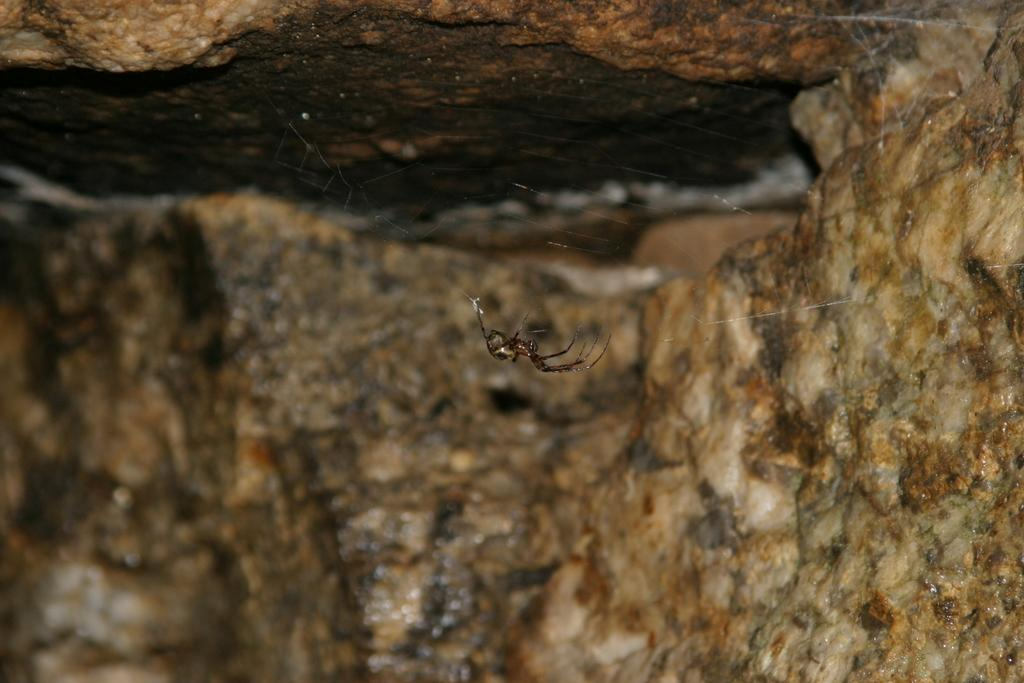What is the main subject of the image? There is a spider in the image. Where is the spider located? The spider is on a web. What is the web attached to? The web is on stones. Can you describe the background of the image? There is a stone visible in the background of the image. What color is the orange that the spider is holding in the image? There is no orange present in the image; the spider is on a web on stones. 